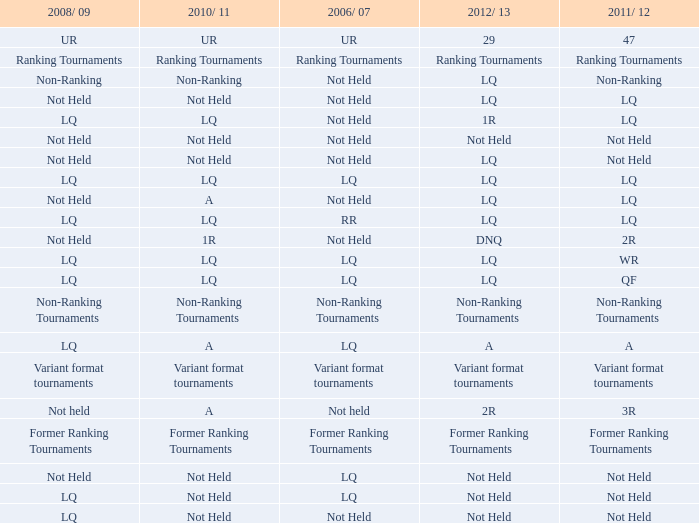What is 2008/09, when 2010/11 is UR? UR. 